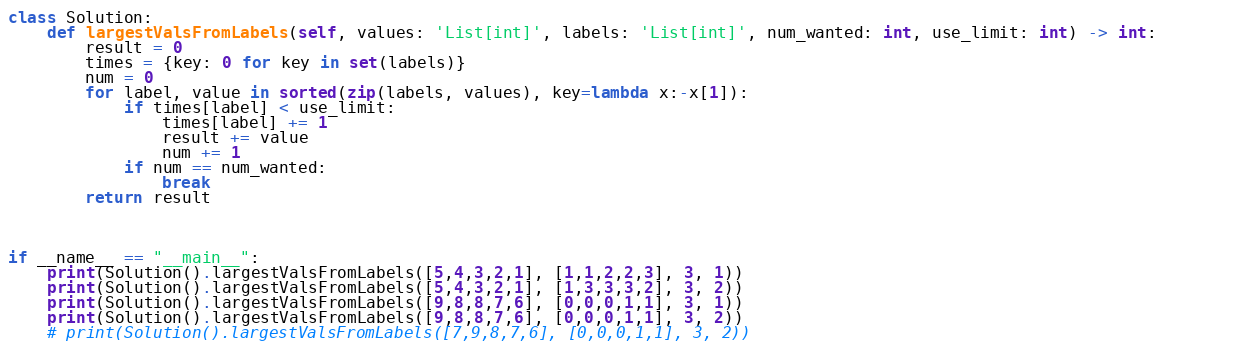Convert code to text. <code><loc_0><loc_0><loc_500><loc_500><_Python_>class Solution:
    def largestValsFromLabels(self, values: 'List[int]', labels: 'List[int]', num_wanted: int, use_limit: int) -> int:        
        result = 0
        times = {key: 0 for key in set(labels)}
        num = 0
        for label, value in sorted(zip(labels, values), key=lambda x:-x[1]):
            if times[label] < use_limit:
                times[label] += 1
                result += value
                num += 1
            if num == num_wanted:
                break
        return result
        


if __name__ == "__main__":
    print(Solution().largestValsFromLabels([5,4,3,2,1], [1,1,2,2,3], 3, 1))
    print(Solution().largestValsFromLabels([5,4,3,2,1], [1,3,3,3,2], 3, 2))
    print(Solution().largestValsFromLabels([9,8,8,7,6], [0,0,0,1,1], 3, 1))
    print(Solution().largestValsFromLabels([9,8,8,7,6], [0,0,0,1,1], 3, 2))
    # print(Solution().largestValsFromLabels([7,9,8,7,6], [0,0,0,1,1], 3, 2))</code> 